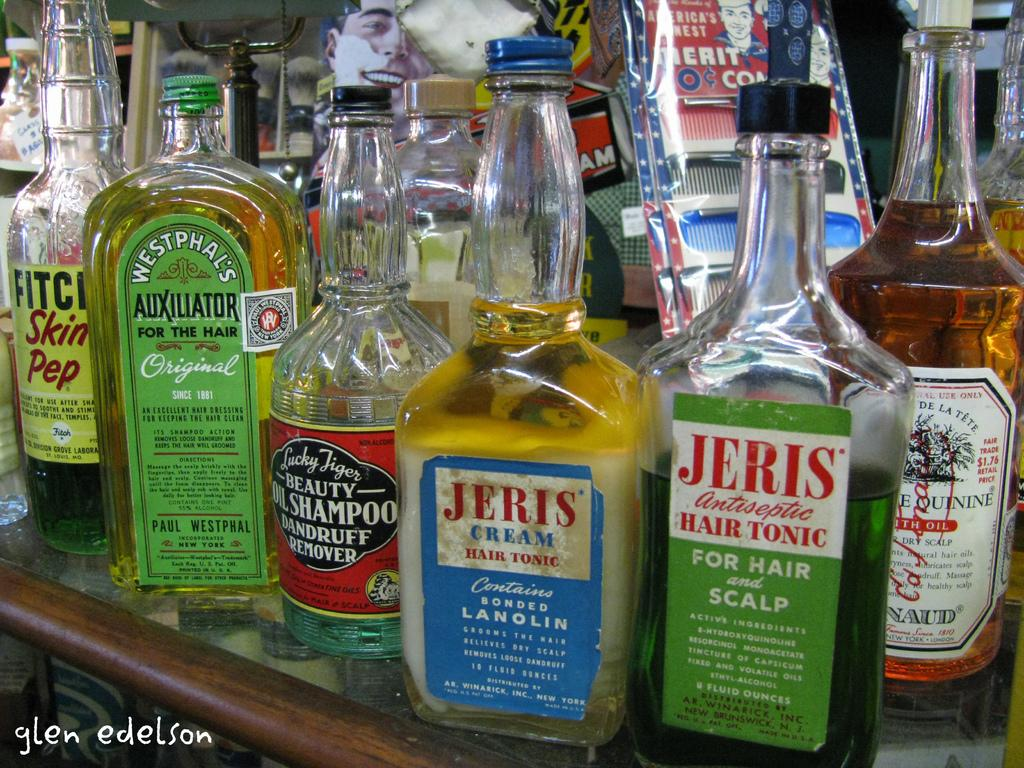<image>
Summarize the visual content of the image. A variety of hair care product bottles are on a shelf that includes Jeris antiseptic hair tonic. 